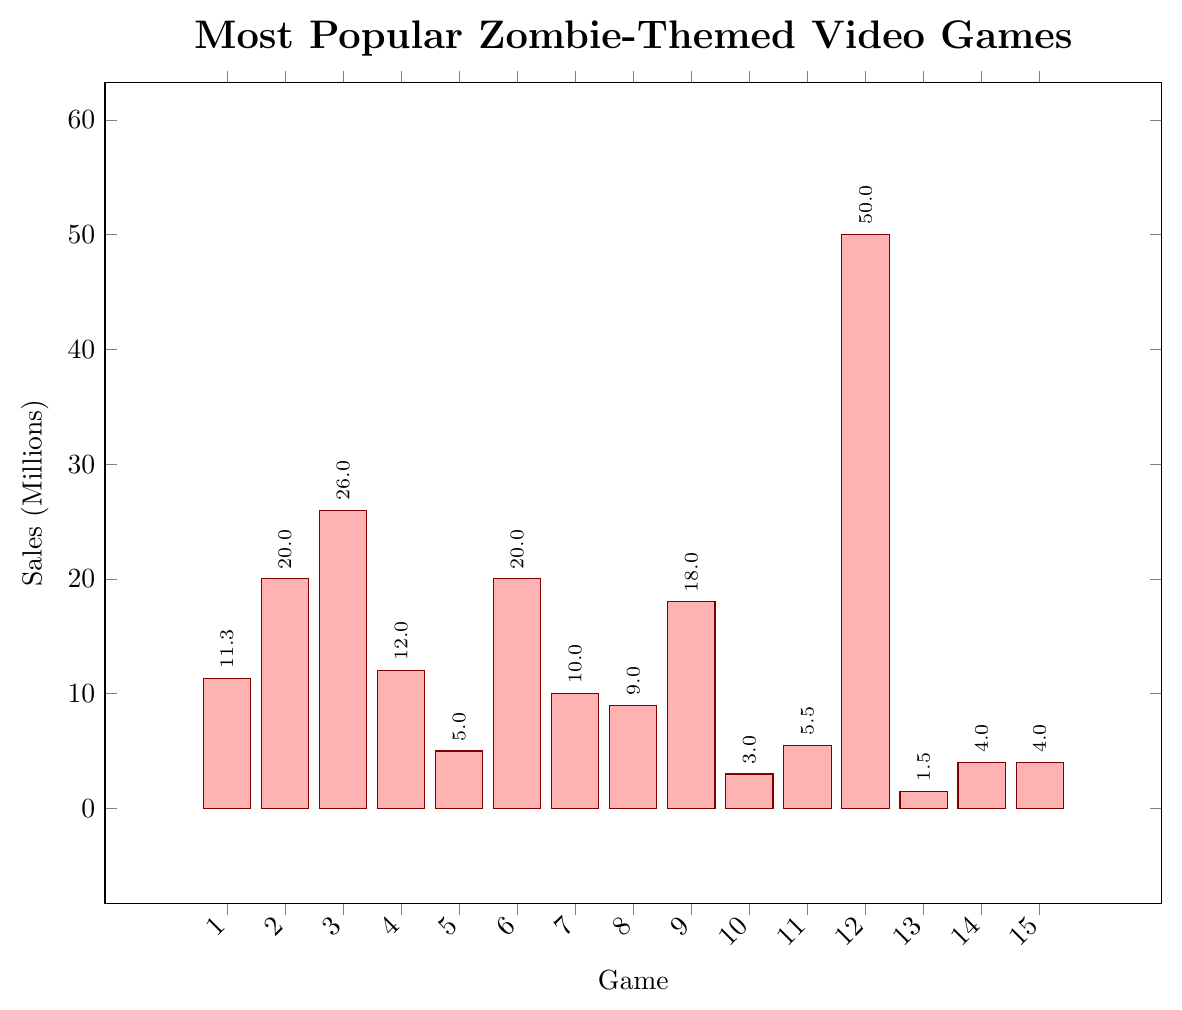Which game has the highest sales figure? The game with the highest sales figure is visually apparent as the tallest bar in the chart. The highest bar corresponds to "Telltale's The Walking Dead" with sales of 50 million.
Answer: Telltale's The Walking Dead Which game has the lowest sales figure? The game with the lowest sales figure can be identified as the shortest bar in the chart. The shortest bar corresponds to "Zombie Army 4: Dead War" with sales of 1.5 million.
Answer: Zombie Army 4: Dead War How do the sales of "Left 4 Dead 2" compare to "Resident Evil 7"? To compare, look at the heights of the bars for "Left 4 Dead 2" and "Resident Evil 7". "Left 4 Dead 2" has a slightly taller bar than "Resident Evil 7", indicating higher sales. "Left 4 Dead 2" has sales of 12 million compared to 11.3 million for "Resident Evil 7".
Answer: Left 4 Dead 2 has higher sales Which games have sales figures between 10 and 20 million? Identify the bars in the middle range (10 to 20 million). The games in this range are "Resident Evil 7", "Left 4 Dead 2", "State of Decay 2", and "Days Gone".
Answer: Resident Evil 7, Left 4 Dead 2, State of Decay 2, Days Gone What is the total sales figure for all the games combined? Sum the sales figures of all the games: 11.3 + 20.0 + 26.0 + 12.0 + 5.0 + 20.0 + 10.0 + 9.0 + 18.0 + 3.0 + 5.5 + 50.0 + 1.5 + 4.0 + 4.0 = 199.3 million.
Answer: 199.3 million What is the average sales figure of the games? The average is calculated by dividing the total sales by the number of games. Total sales is 199.3 million, and there are 15 games. So, 199.3 / 15 = 13.29 million.
Answer: 13.29 million How much more successful is "The Last of Us" compared to "Days Gone" based on sales? Subtract the sales figures of "Days Gone" from "The Last of Us". "The Last of Us" has 20 million, and "Days Gone" has 9 million. So, 20 - 9 = 11 million.
Answer: 11 million Which game sold the closest amount to "Plants vs. Zombies"? Compare the sales figures. "Plants vs. Zombies" has 18 million in sales. "The Last of Us" and "Dying Light" both have 20 million, which are the closest.
Answer: The Last of Us and Dying Light How many games have sales figures less than 5 million? Count the number of bars with heights representing sales less than 5 million. The games are "Dead Rising", "Zombie Army 4: Dead War", "7 Days to Die", and "Dead Space", totaling 4 games.
Answer: 4 games 